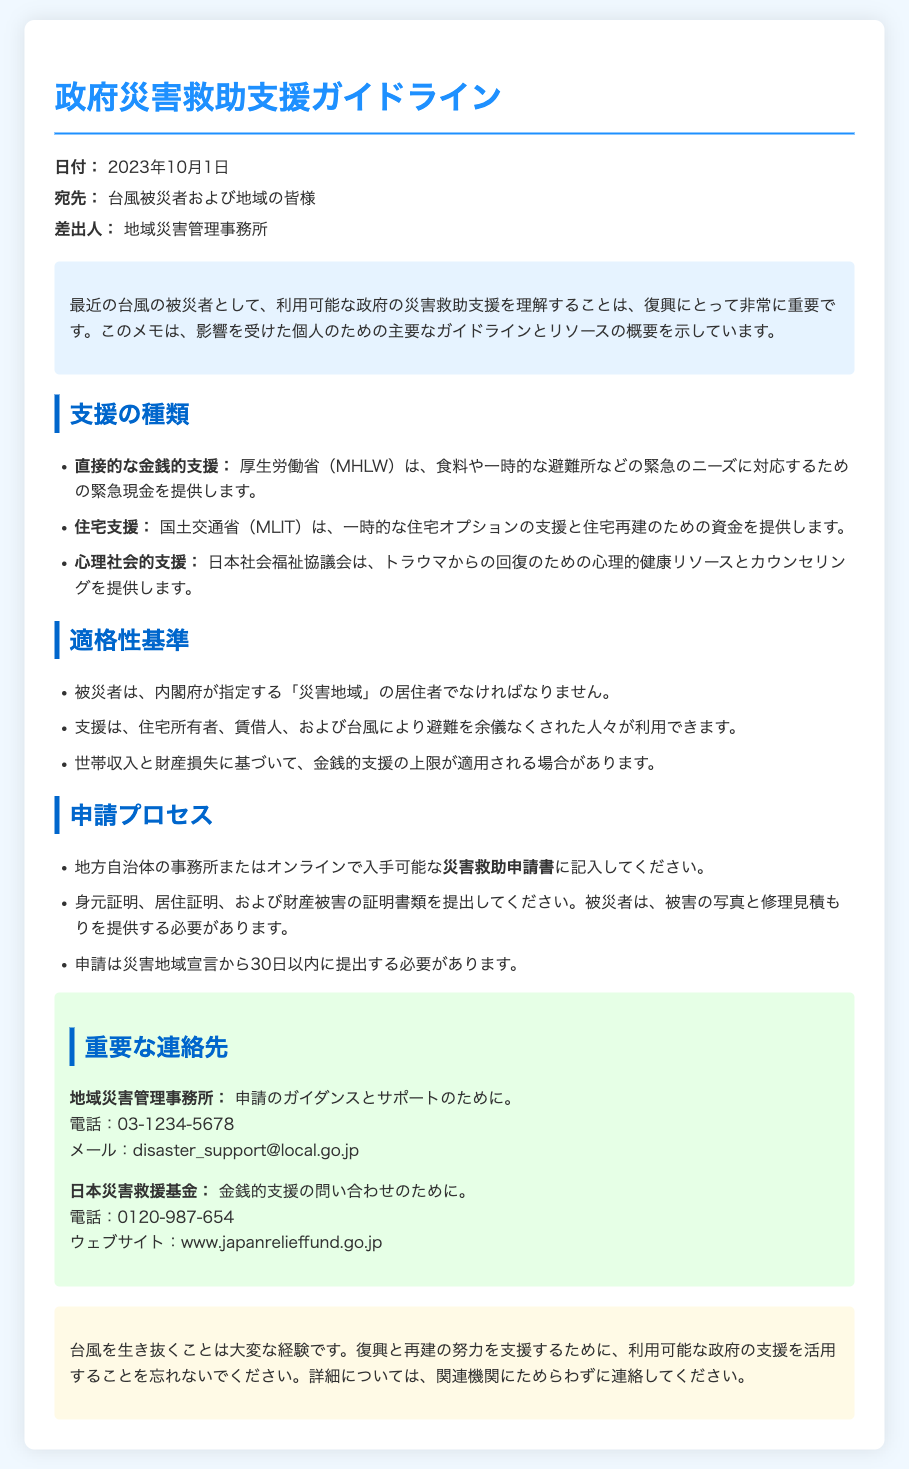What is the date of the memo? The date of the memo is provided in the header section.
Answer: 2023年10月1日 Who is the sender of the memo? The sender of the memo is mentioned in the header section.
Answer: 地域災害管理事務所 What type of support does MHLW provide? The type of support is listed under "支援の種類" in the document.
Answer: 直接的な金銭的支援 What is required for eligibility of the assistance? The eligibility criteria are outlined under "適格性基準".
Answer: 災害地域の居住者 How long after the disaster declaration should applications be submitted? This information is specified in the "申請プロセス" section.
Answer: 30日以内 What department offers psychological support? The department providing this kind of support is mentioned in the list of support types.
Answer: 日本社会福祉協議会 What document must be filled out for the assistance? The document name is specified in the "申請プロセス" section.
Answer: 災害救助申請書 What is one key contact number provided for disaster guidance? This contact number is mentioned in the contact section of the memo.
Answer: 03-1234-5678 What type of support does MLIT provide? The type of support is listed under "支援の種類".
Answer: 住宅支援 